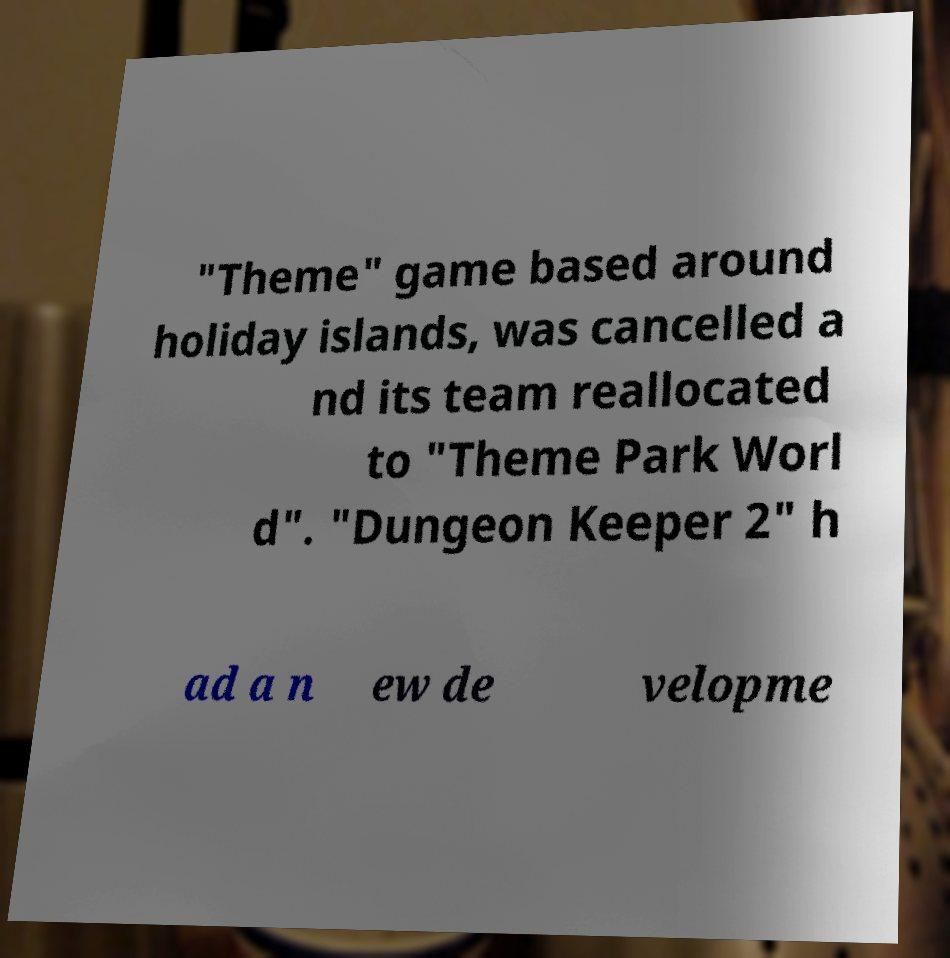Please identify and transcribe the text found in this image. "Theme" game based around holiday islands, was cancelled a nd its team reallocated to "Theme Park Worl d". "Dungeon Keeper 2" h ad a n ew de velopme 